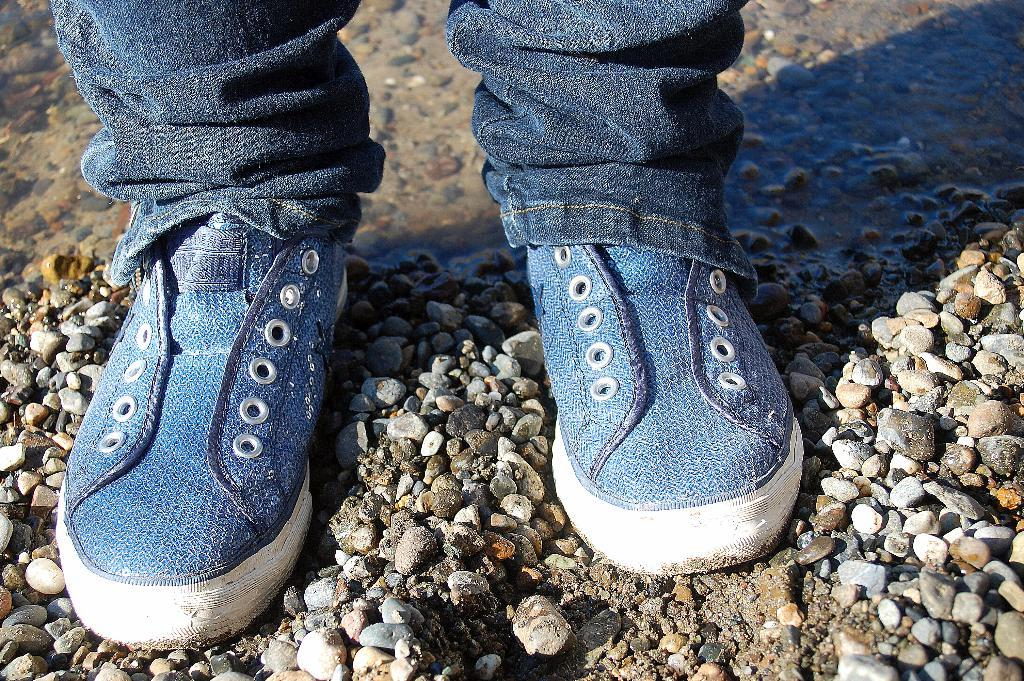What body parts are visible in the image? Human legs are visible in the image. What natural element is present in the image? There is water in the image. What type of terrain is depicted in the image? There are stones on the ground in the image. What type of footwear is worn by the person in the image? Blue color shoes are present in the image. How does the person in the image pull the parcel out of the water? There is no parcel present in the image, so it is not possible to answer that question. 